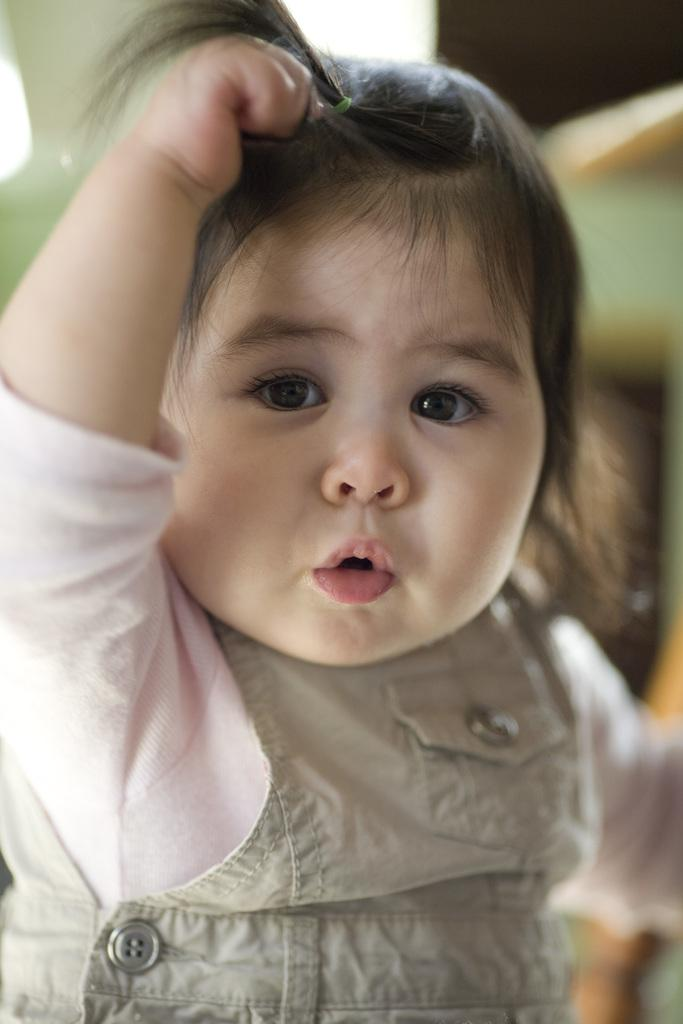What is the main subject of the image? There is a baby in the image. Can you describe the baby's clothing? The baby is wearing a pink and grey colored dress. How would you describe the background of the image? The background of the image is blurry. What type of glass is the baby holding in the image? There is no glass present in the image; the baby is not holding anything. 